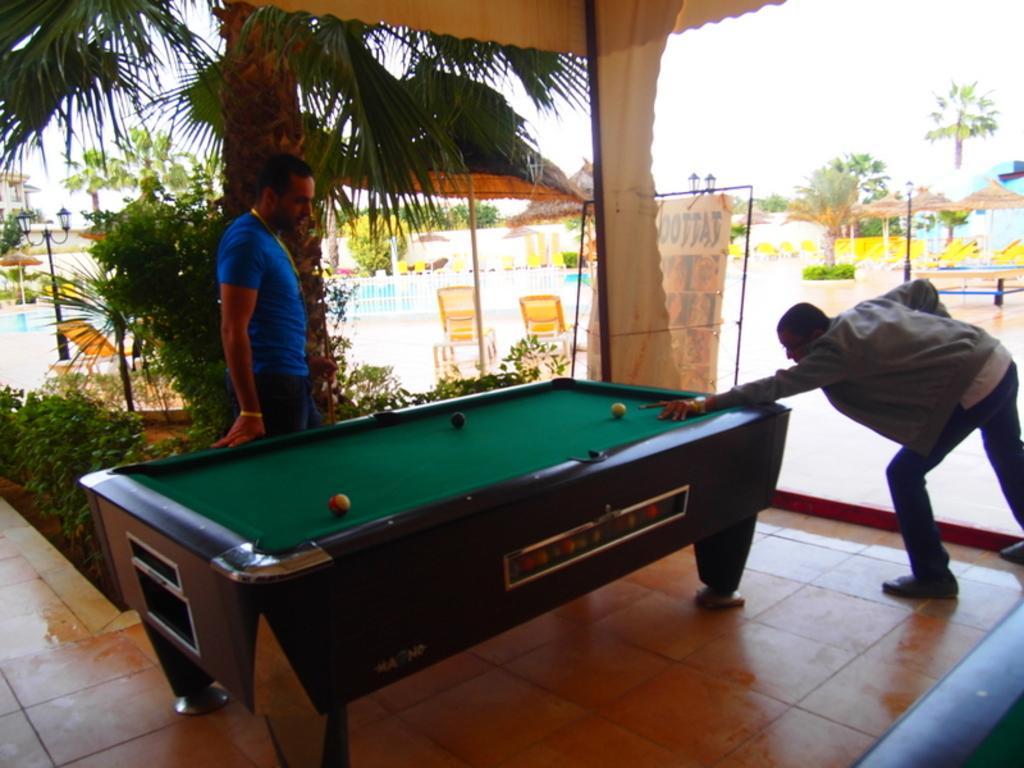Can you describe this image briefly? A person wearing a gray jacket is holding a billiard stick and playing billiard. A person wearing a blue shirt is looking the billiard table. And there is a tree behind this person. And in the background there are chairs and an umbrella. Some trees are there in the background. 